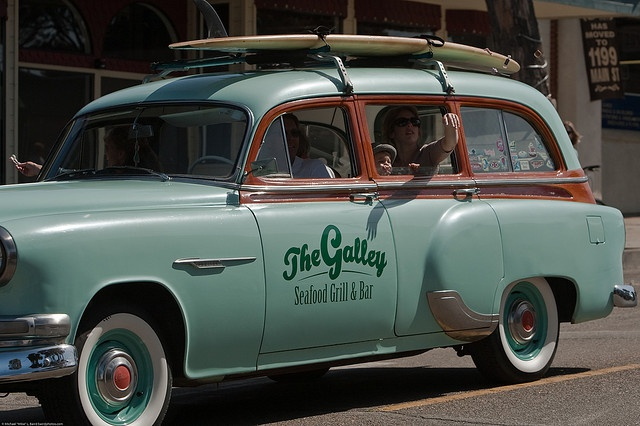Describe the objects in this image and their specific colors. I can see car in black, gray, and darkgray tones, surfboard in black and gray tones, people in black, gray, and maroon tones, people in black, maroon, and gray tones, and people in black and gray tones in this image. 